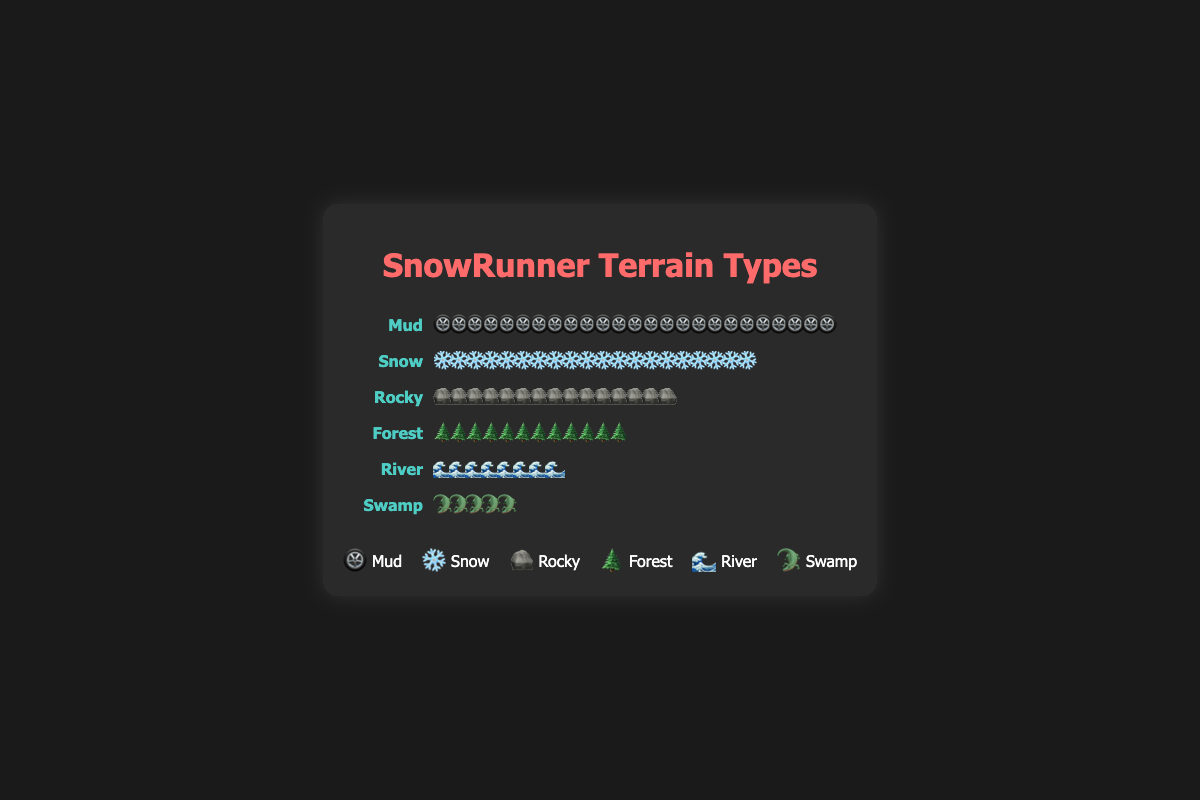Which terrain type is encountered most frequently in SnowRunner missions? The terrain type with the highest number of icons in the plot is the most frequently encountered. Mud has 25 icons, more than any other terrain type.
Answer: Mud How many terrain types are represented in the plot? Count the number of distinct terrain names listed in the plot. There are 6 terrain types: Mud, Snow, Rocky, Forest, River, and Swamp.
Answer: 6 Which terrain type is encountered least frequently in SnowRunner missions? Look for the terrain type with the fewest icons. Swamp has 5 icons, fewer than any other terrain type.
Answer: Swamp How many missions involve snowy terrain compared to rocky terrain? Count the number of icons for Snow and Rocky. Snow has 20 icons, and Rocky has 15 icons. Snow has 5 more missions involving snowy terrain than rocky terrain.
Answer: 5 What is the total number of missions involving either Forest or River terrain? Add the number of icons for Forest and River terrains. Forest has 12 icons, and River has 8 icons, so the total is 12 + 8 = 20 missions.
Answer: 20 Which terrain type uses an icon of a snowflake? Identify the terrain type associated with the snowflake icon (❄️). This is Snow.
Answer: Snow How many more missions are there involving Mud than Swamp? Subtract the number of Swamp icons from the number of Mud icons. Mud has 25 icons and Swamp has 5 icons, so the difference is 25 - 5 = 20 missions.
Answer: 20 What percentage of the total missions is represented by Rocky terrain? Calculate the total number of missions first by summing all icons (25 + 20 + 15 + 12 + 8 + 5 = 85), then divide the number of Rocky terrain missions by the total and multiply by 100. (15 / 85) * 100 ≈ 17.65%
Answer: 17.65% If each icon represents 1 mission, how many mission types have fewer than 10 missions? Count the terrain types where the number of icons is less than 10. River has 8 icons, and Swamp has 5 icons. There are 2 terrain types with fewer than 10 missions.
Answer: 2 Is the number of Forest missions greater than the number of River and Swamp missions combined? Add the number of icons for River (8) and Swamp (5), and compare it to the number of Forest icons (12). 8 + 5 = 13, which is greater than 12, so the number of Forest missions is not greater.
Answer: No 